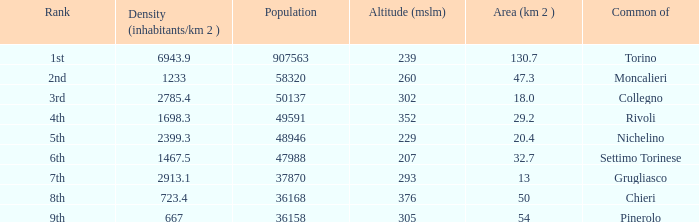What rank is the common with an area of 47.3 km^2? 2nd. 